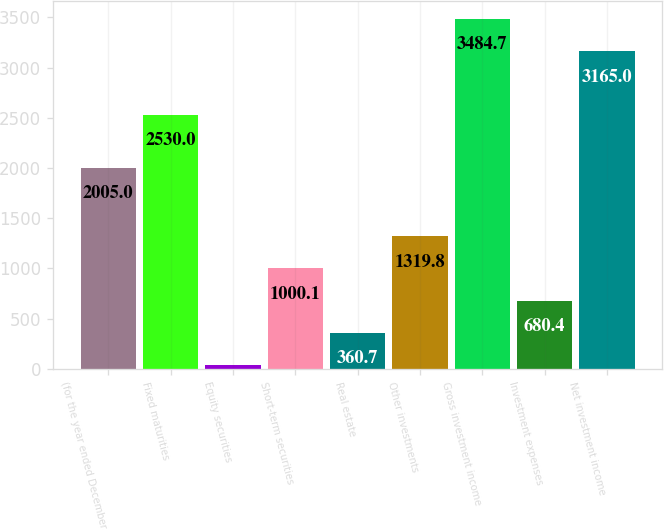<chart> <loc_0><loc_0><loc_500><loc_500><bar_chart><fcel>(for the year ended December<fcel>Fixed maturities<fcel>Equity securities<fcel>Short-term securities<fcel>Real estate<fcel>Other investments<fcel>Gross investment income<fcel>Investment expenses<fcel>Net investment income<nl><fcel>2005<fcel>2530<fcel>41<fcel>1000.1<fcel>360.7<fcel>1319.8<fcel>3484.7<fcel>680.4<fcel>3165<nl></chart> 